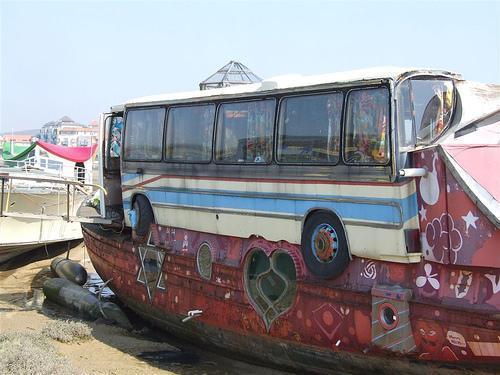How many tires are shown?
Give a very brief answer. 2. 